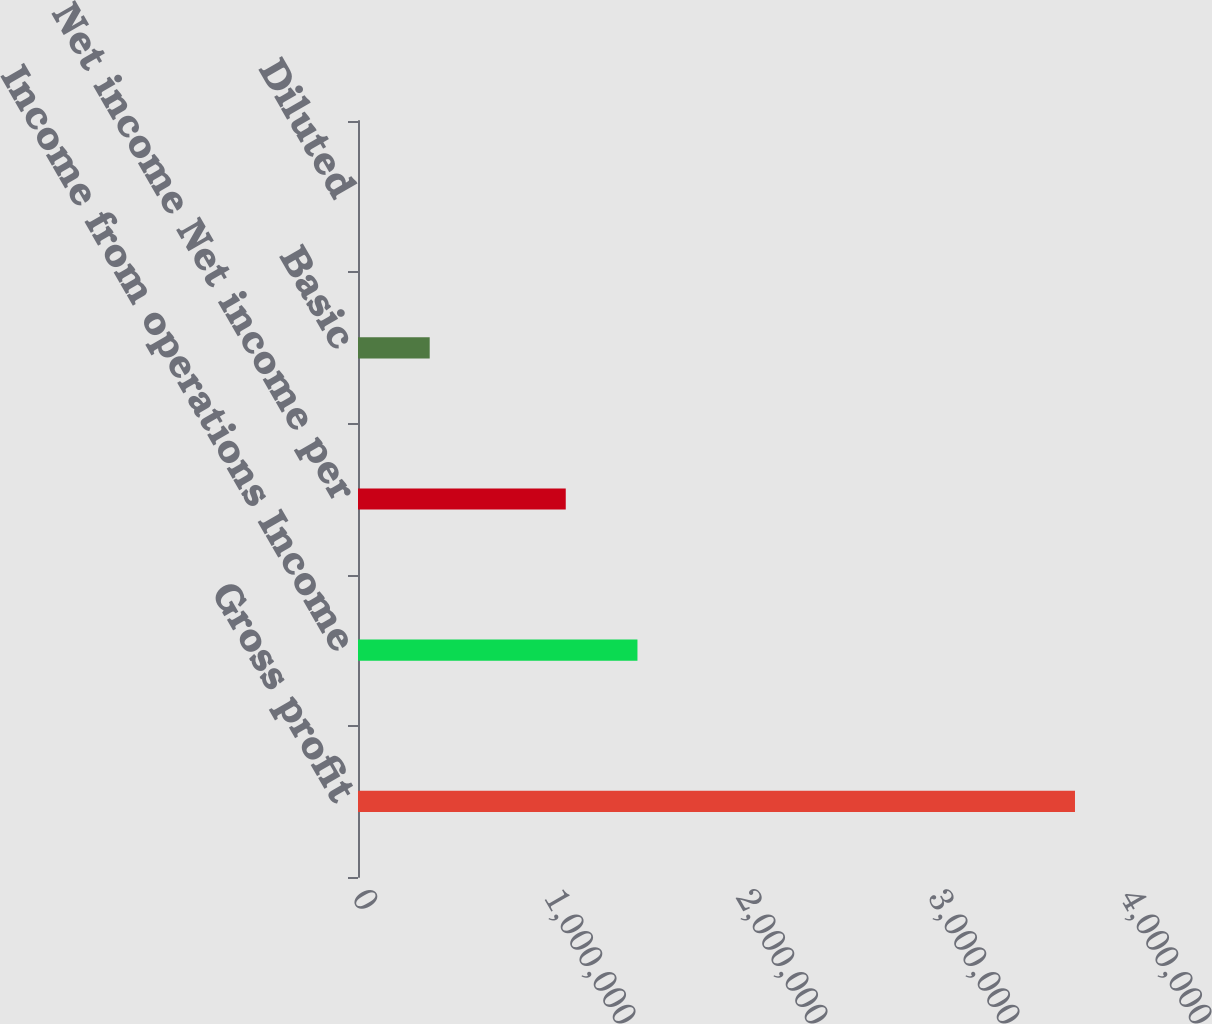Convert chart to OTSL. <chart><loc_0><loc_0><loc_500><loc_500><bar_chart><fcel>Gross profit<fcel>Income from operations Income<fcel>Net income Net income per<fcel>Basic<fcel>Diluted<nl><fcel>3.7343e+06<fcel>1.45547e+06<fcel>1.08204e+06<fcel>373430<fcel>0.78<nl></chart> 